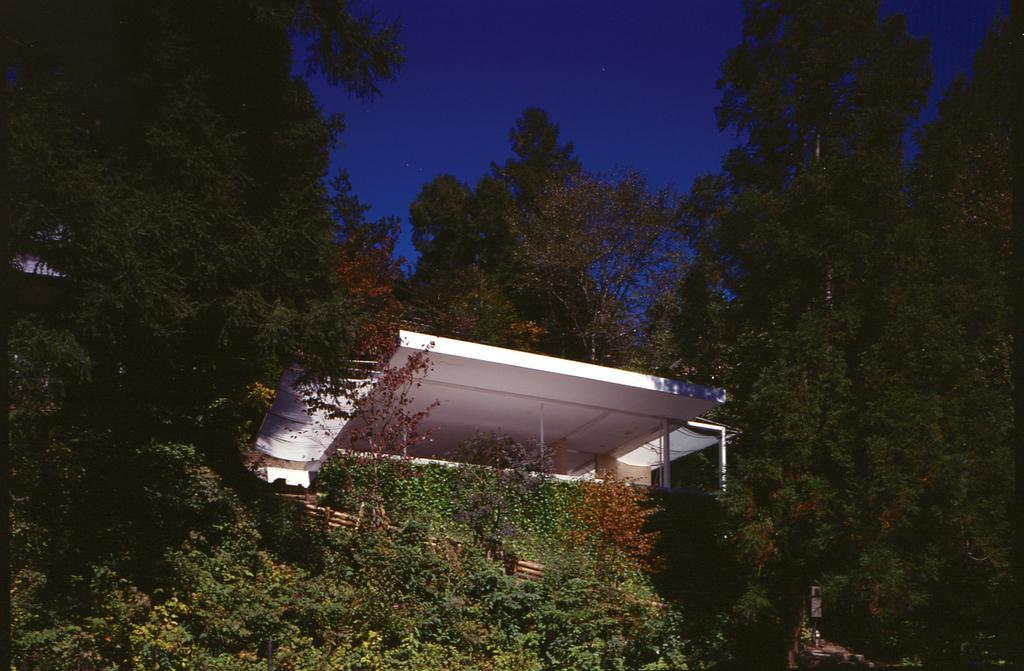Please provide a concise description of this image. In this image I can see a shed in white color. Background I can see trees in green color and sky in blue color. 